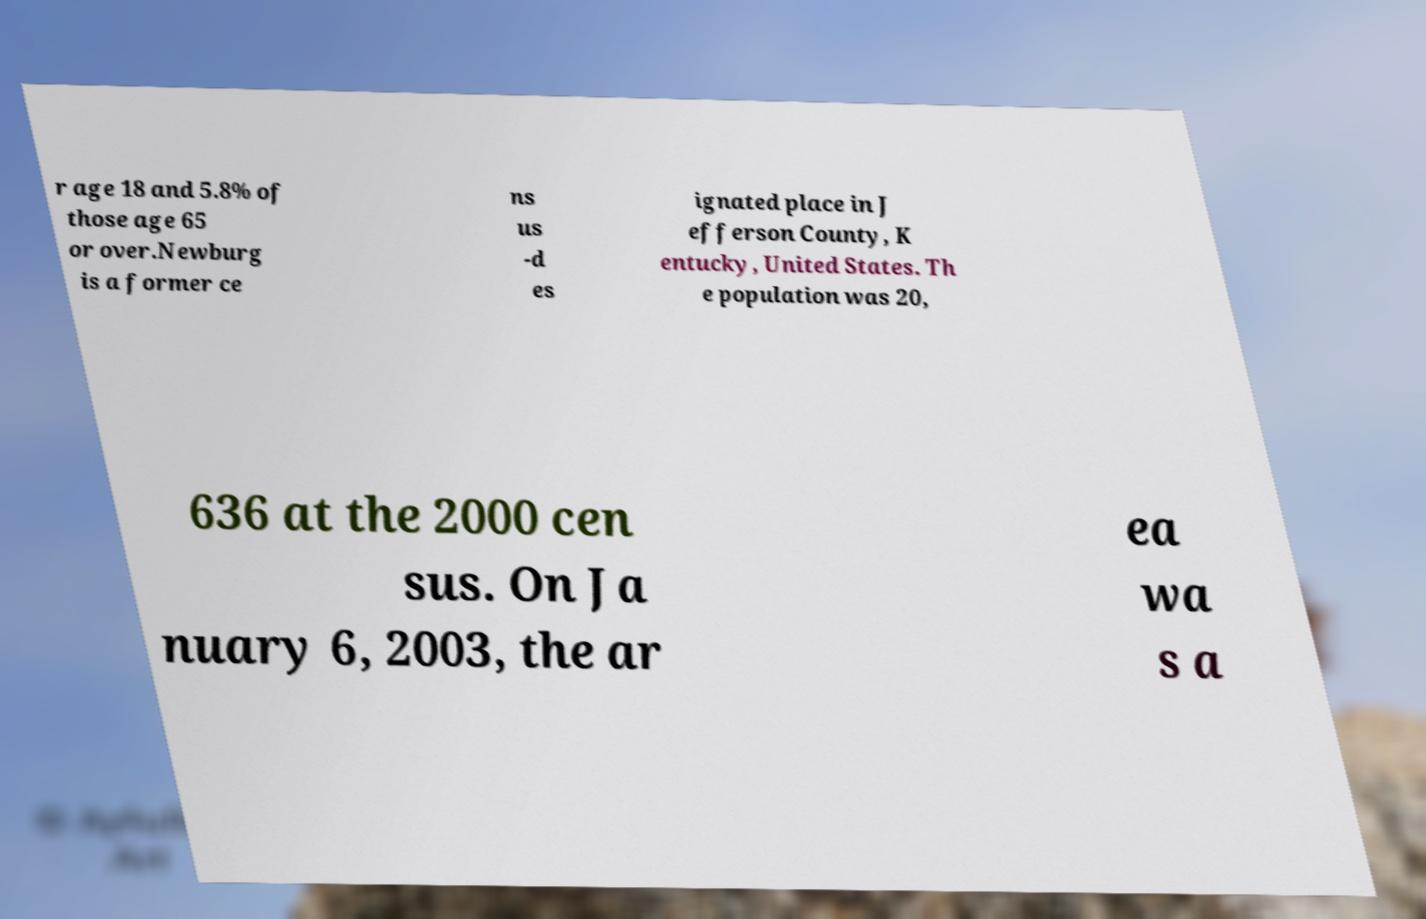Can you read and provide the text displayed in the image?This photo seems to have some interesting text. Can you extract and type it out for me? r age 18 and 5.8% of those age 65 or over.Newburg is a former ce ns us -d es ignated place in J efferson County, K entucky, United States. Th e population was 20, 636 at the 2000 cen sus. On Ja nuary 6, 2003, the ar ea wa s a 